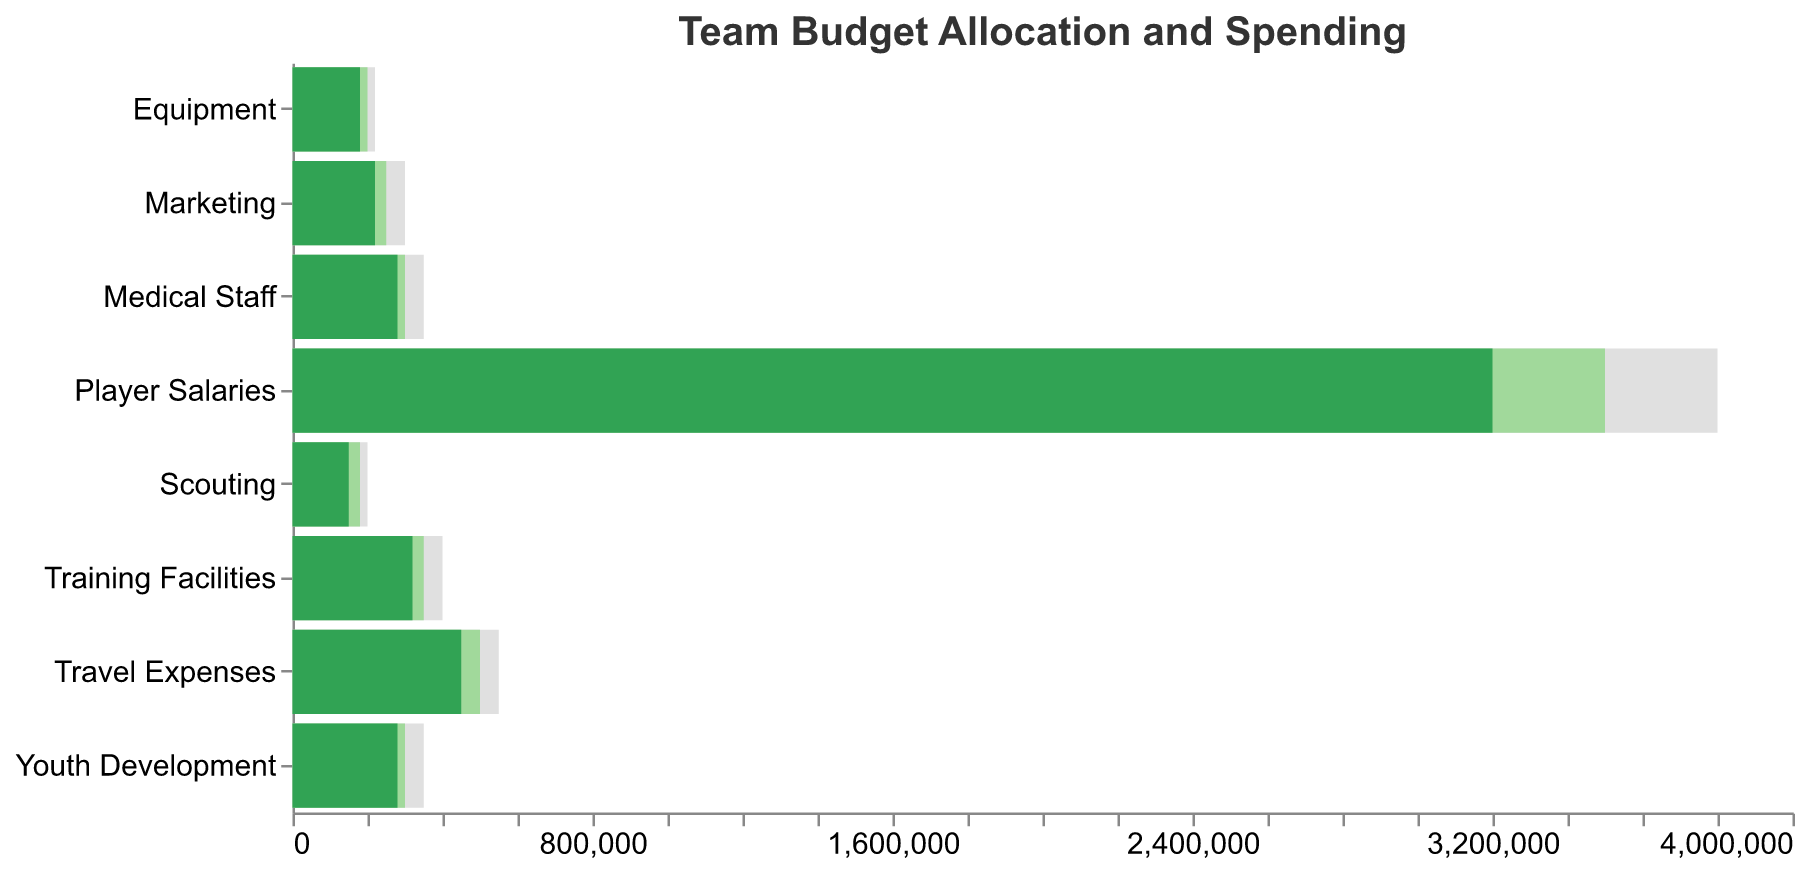What's the total budget for Marketing and Scouting categories? Add the budget for Marketing ($250,000) and the budget for Scouting ($180,000). The total budget is $250,000 + $180,000 = $430,000.
Answer: $430,000 What is the difference between the actual spending and the target for Player Salaries? Subtract the actual spending ($3,200,000) from the target amount ($3,800,000). The difference is $3,800,000 - $3,200,000 = $600,000.
Answer: $600,000 Which category has the closest actual spending to its target amount? Compare the actual spending and the target amounts for all categories to find the smallest difference: 
- Player Salaries: $600,000
- Equipment: $40,000
- Travel Expenses: $100,000
- Training Facilities: $80,000
- Medical Staff: $70,000
- Scouting: $50,000
- Marketing: $80,000
- Youth Development: $70,000
The Equipment category has the smallest difference of $40,000.
Answer: Equipment How many categories have actual spending exceeding their budget? Compare actual spending to the budget for each category:
- Player Salaries: $3,200,000 < $3,500,000 (No)
- Equipment: $180,000 < $200,000 (No)
- Travel Expenses: $450,000 < $500,000 (No)
- Training Facilities: $320,000 < $350,000 (No)
- Medical Staff: $280,000 < $300,000 (No)
- Scouting: $150,000 < $180,000 (No)
- Marketing: $220,000 < $250,000 (No)
- Youth Development: $280,000 < $300,000 (No)
None of the categories have actual spending exceeding their budget.
Answer: 0 Which category has the highest actual spending compared to its budget? Calculate the ratio of actual spending to budget for each category:
- Player Salaries: $3,200,000 / $3,500,000 = 0.914
- Equipment: $180,000 / $200,000 = 0.900
- Travel Expenses: $450,000 / $500,000 = 0.900
- Training Facilities: $320,000 / $350,000 = 0.914
- Medical Staff: $280,000 / $300,000 = 0.933
- Scouting: $150,000 / $180,000 = 0.833
- Marketing: $220,000 / $250,000 = 0.880
- Youth Development: $280,000 / $300,000 = 0.933
Medical Staff and Youth Development both have the highest ratio of 0.933.
Answer: Medical Staff and Youth Development What is the average target amount across all categories? Calculate the total target amount and divide by the number of categories:
- Total target amount = $3,800,000 + $220,000 + $550,000 + $400,000 + $350,000 + $200,000 + $300,000 + $350,000 = $6,170,000
- Number of categories = 8
- Average target amount = $6,170,000 / 8 = $771,250
Answer: $771,250 